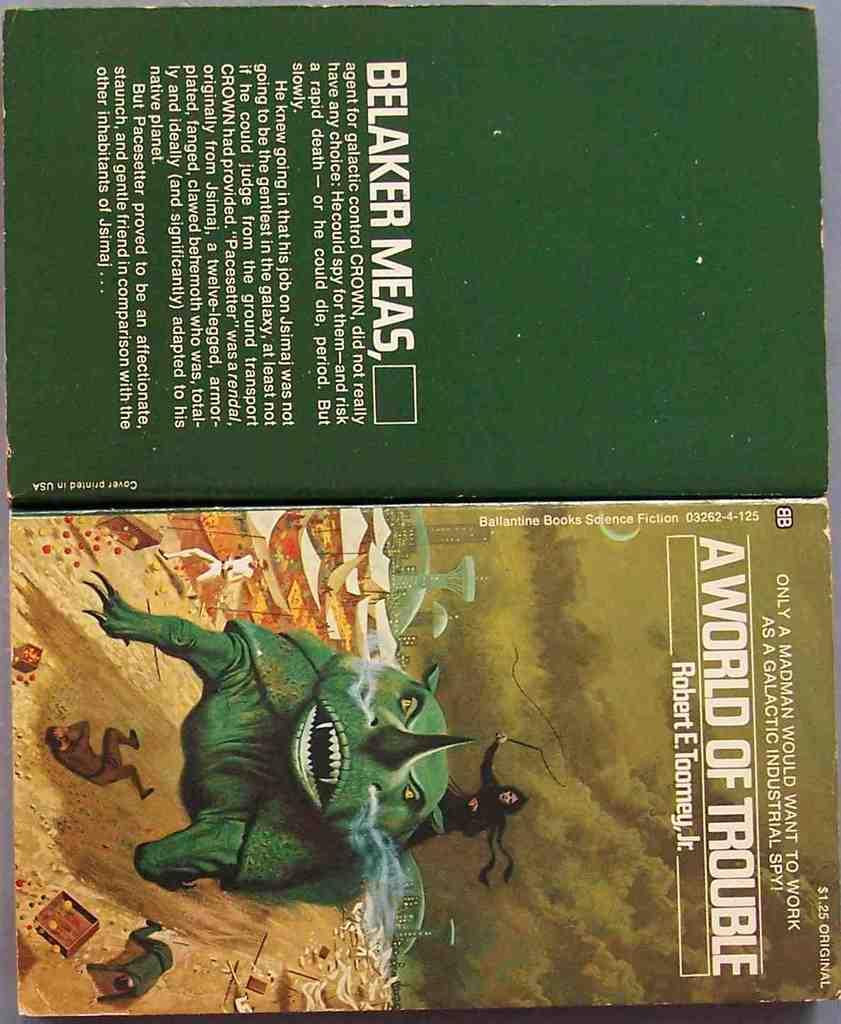<image>
Present a compact description of the photo's key features. The book A World of Trouble has a green creature on the cover. 